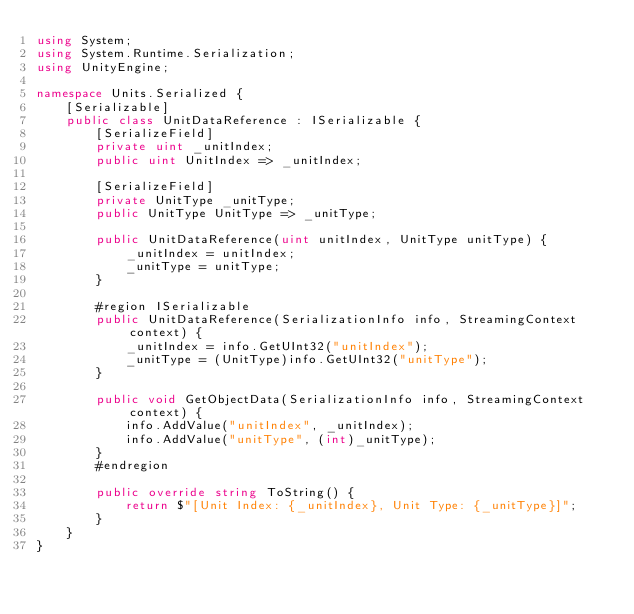<code> <loc_0><loc_0><loc_500><loc_500><_C#_>using System;
using System.Runtime.Serialization;
using UnityEngine;

namespace Units.Serialized {
    [Serializable]
    public class UnitDataReference : ISerializable {
        [SerializeField]
        private uint _unitIndex;
        public uint UnitIndex => _unitIndex;

        [SerializeField]
        private UnitType _unitType;
        public UnitType UnitType => _unitType;

        public UnitDataReference(uint unitIndex, UnitType unitType) {
            _unitIndex = unitIndex;
            _unitType = unitType;
        }
        
        #region ISerializable
        public UnitDataReference(SerializationInfo info, StreamingContext context) {
            _unitIndex = info.GetUInt32("unitIndex");
            _unitType = (UnitType)info.GetUInt32("unitType");
        }
        
        public void GetObjectData(SerializationInfo info, StreamingContext context) {
            info.AddValue("unitIndex", _unitIndex);
            info.AddValue("unitType", (int)_unitType);
        }
        #endregion

        public override string ToString() {
            return $"[Unit Index: {_unitIndex}, Unit Type: {_unitType}]";
        }
    }
}</code> 